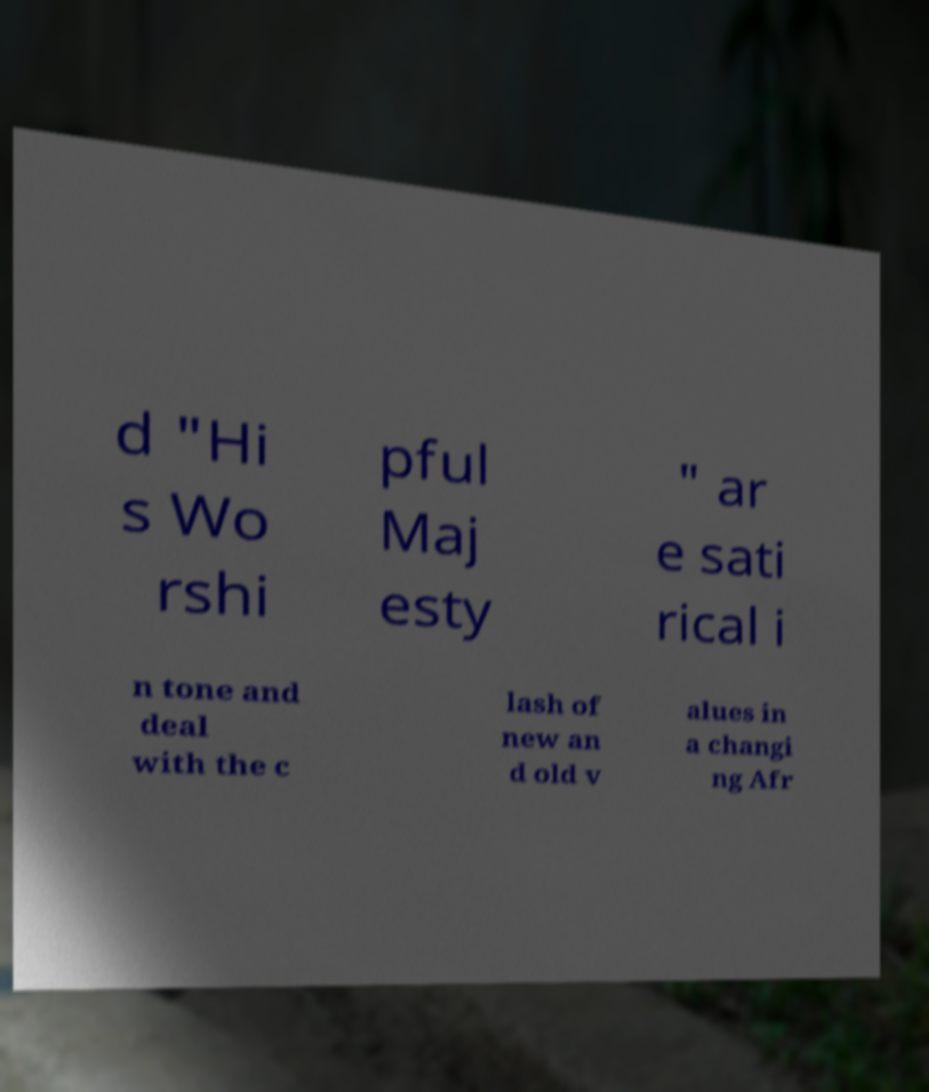There's text embedded in this image that I need extracted. Can you transcribe it verbatim? d "Hi s Wo rshi pful Maj esty " ar e sati rical i n tone and deal with the c lash of new an d old v alues in a changi ng Afr 